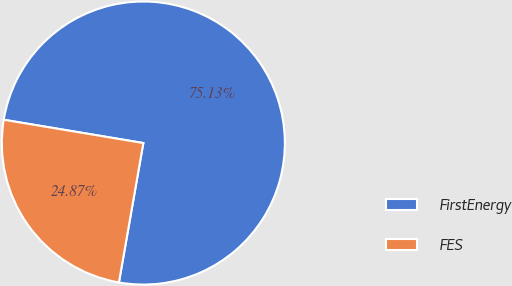<chart> <loc_0><loc_0><loc_500><loc_500><pie_chart><fcel>FirstEnergy<fcel>FES<nl><fcel>75.13%<fcel>24.87%<nl></chart> 